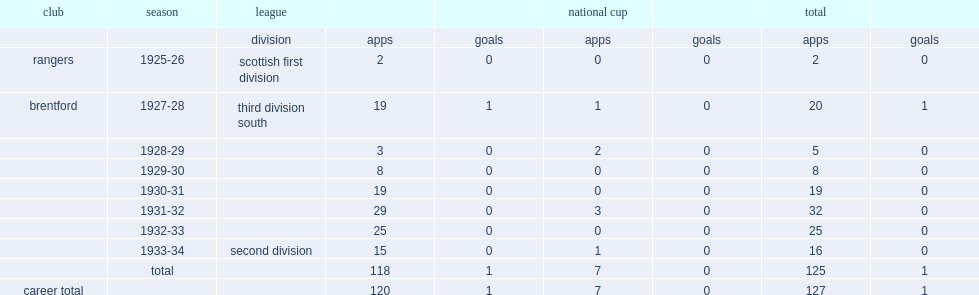How many appearances did hodge make in brentford? 125.0. How many goals did hodge score in brentford? 1.0. 